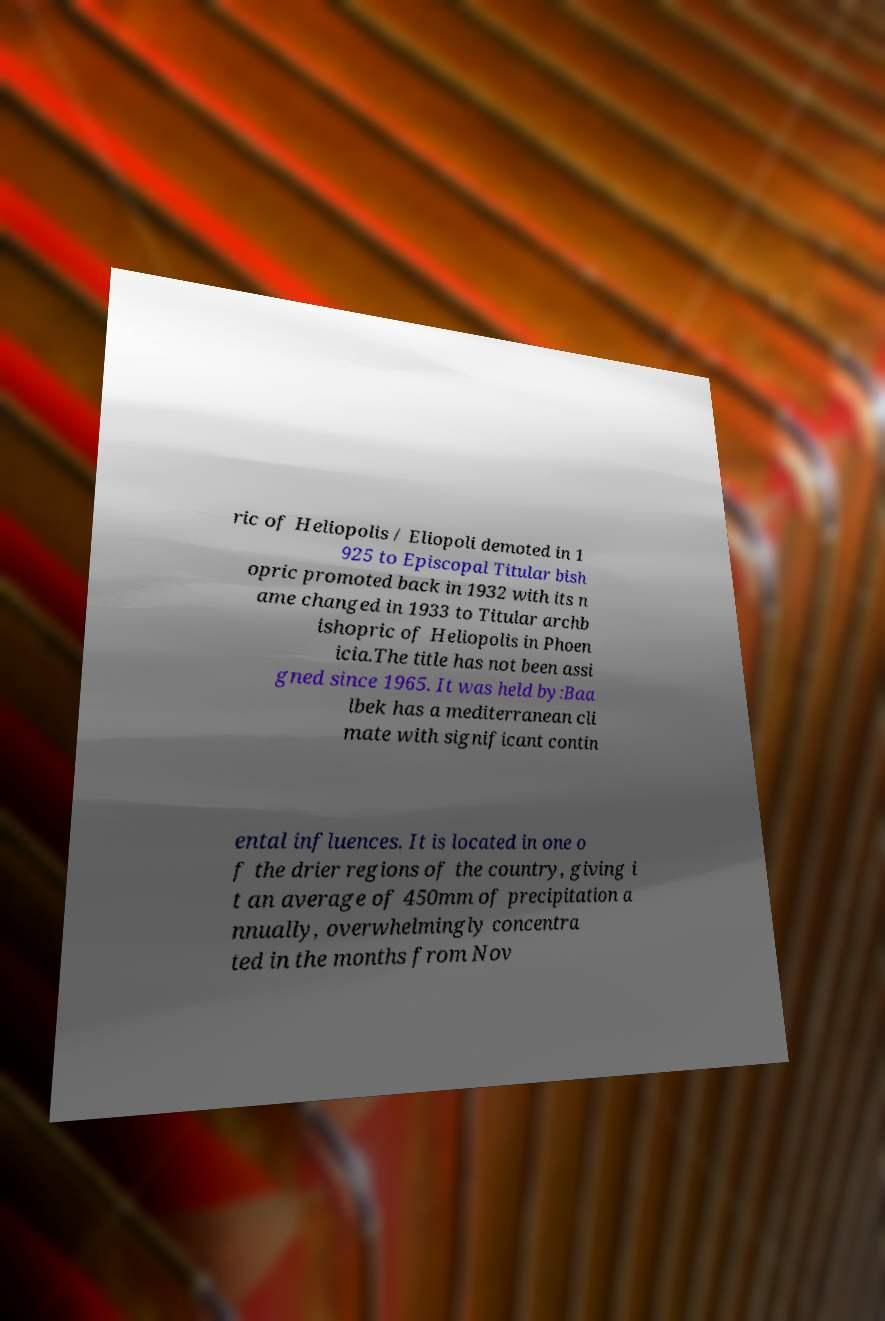For documentation purposes, I need the text within this image transcribed. Could you provide that? ric of Heliopolis / Eliopoli demoted in 1 925 to Episcopal Titular bish opric promoted back in 1932 with its n ame changed in 1933 to Titular archb ishopric of Heliopolis in Phoen icia.The title has not been assi gned since 1965. It was held by:Baa lbek has a mediterranean cli mate with significant contin ental influences. It is located in one o f the drier regions of the country, giving i t an average of 450mm of precipitation a nnually, overwhelmingly concentra ted in the months from Nov 